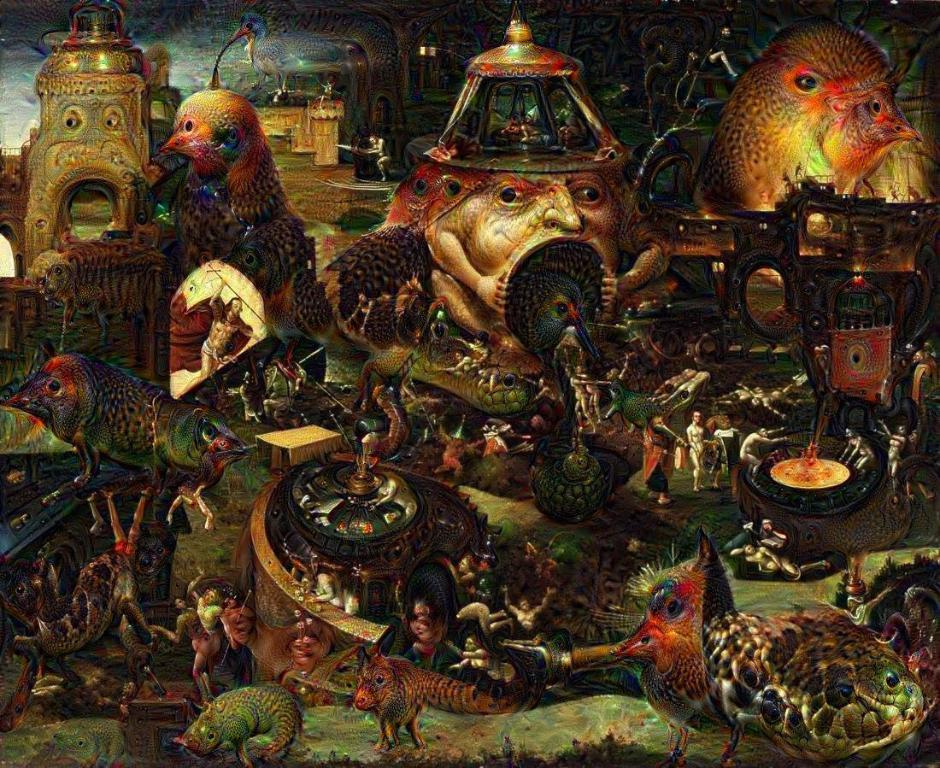What is the main subject of the image? The image contains an art work. Are there any people in the image? Yes, there are persons in the image. What other living creatures can be seen in the image? There are animals and birds in the image. Can you see a match being lit in the image? There is no match present in the image. What rule is being enforced by the persons in the image? The image does not depict any rules or enforcement; it is focused on the art work and the living creatures present. 